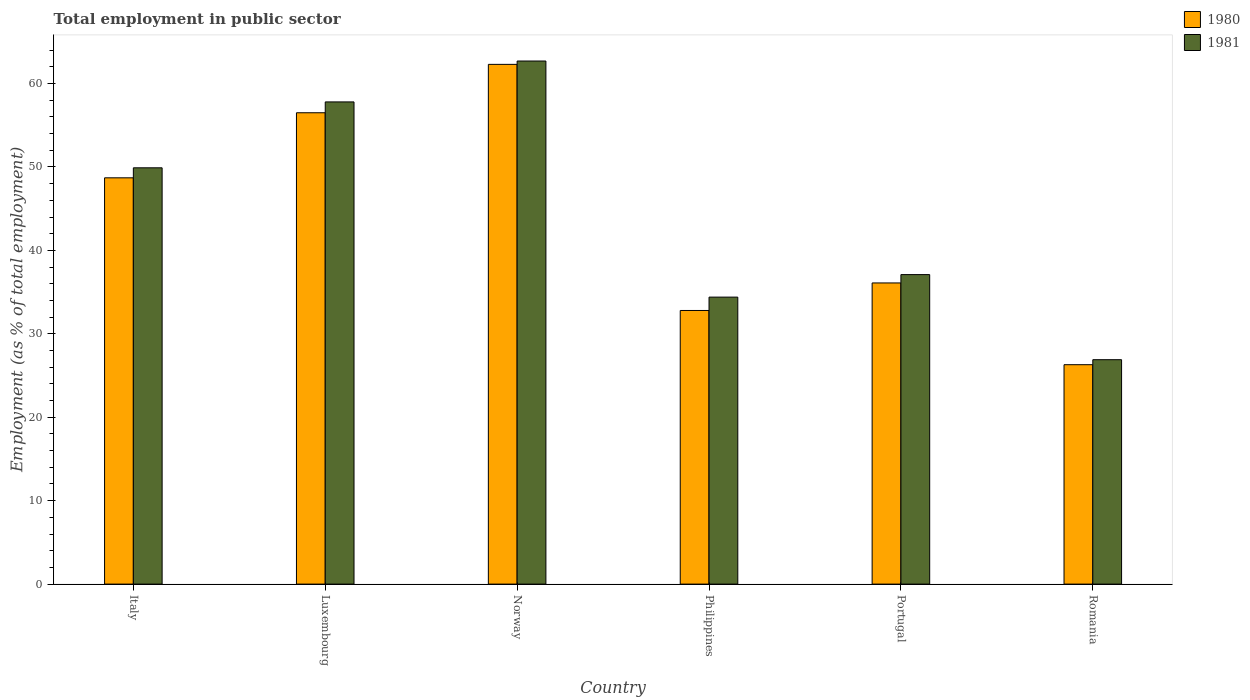How many different coloured bars are there?
Your answer should be compact. 2. How many groups of bars are there?
Your answer should be very brief. 6. How many bars are there on the 2nd tick from the right?
Your answer should be very brief. 2. What is the label of the 6th group of bars from the left?
Offer a terse response. Romania. What is the employment in public sector in 1981 in Luxembourg?
Provide a short and direct response. 57.8. Across all countries, what is the maximum employment in public sector in 1981?
Ensure brevity in your answer.  62.7. Across all countries, what is the minimum employment in public sector in 1981?
Your answer should be compact. 26.9. In which country was the employment in public sector in 1981 minimum?
Offer a very short reply. Romania. What is the total employment in public sector in 1980 in the graph?
Your response must be concise. 262.7. What is the difference between the employment in public sector in 1980 in Italy and that in Romania?
Keep it short and to the point. 22.4. What is the difference between the employment in public sector in 1980 in Romania and the employment in public sector in 1981 in Italy?
Your response must be concise. -23.6. What is the average employment in public sector in 1981 per country?
Give a very brief answer. 44.8. What is the difference between the employment in public sector of/in 1981 and employment in public sector of/in 1980 in Philippines?
Offer a terse response. 1.6. In how many countries, is the employment in public sector in 1981 greater than 16 %?
Keep it short and to the point. 6. What is the ratio of the employment in public sector in 1981 in Italy to that in Portugal?
Your response must be concise. 1.35. Is the employment in public sector in 1980 in Luxembourg less than that in Romania?
Provide a short and direct response. No. What is the difference between the highest and the second highest employment in public sector in 1981?
Make the answer very short. -4.9. What is the difference between the highest and the lowest employment in public sector in 1980?
Make the answer very short. 36. In how many countries, is the employment in public sector in 1980 greater than the average employment in public sector in 1980 taken over all countries?
Keep it short and to the point. 3. What does the 1st bar from the left in Luxembourg represents?
Offer a terse response. 1980. What does the 2nd bar from the right in Philippines represents?
Make the answer very short. 1980. Does the graph contain any zero values?
Your answer should be compact. No. How many legend labels are there?
Provide a succinct answer. 2. What is the title of the graph?
Provide a short and direct response. Total employment in public sector. What is the label or title of the Y-axis?
Keep it short and to the point. Employment (as % of total employment). What is the Employment (as % of total employment) in 1980 in Italy?
Offer a terse response. 48.7. What is the Employment (as % of total employment) of 1981 in Italy?
Provide a succinct answer. 49.9. What is the Employment (as % of total employment) in 1980 in Luxembourg?
Keep it short and to the point. 56.5. What is the Employment (as % of total employment) in 1981 in Luxembourg?
Your answer should be very brief. 57.8. What is the Employment (as % of total employment) of 1980 in Norway?
Keep it short and to the point. 62.3. What is the Employment (as % of total employment) in 1981 in Norway?
Your answer should be very brief. 62.7. What is the Employment (as % of total employment) of 1980 in Philippines?
Make the answer very short. 32.8. What is the Employment (as % of total employment) in 1981 in Philippines?
Your answer should be very brief. 34.4. What is the Employment (as % of total employment) of 1980 in Portugal?
Offer a very short reply. 36.1. What is the Employment (as % of total employment) in 1981 in Portugal?
Your answer should be compact. 37.1. What is the Employment (as % of total employment) in 1980 in Romania?
Ensure brevity in your answer.  26.3. What is the Employment (as % of total employment) of 1981 in Romania?
Provide a short and direct response. 26.9. Across all countries, what is the maximum Employment (as % of total employment) in 1980?
Give a very brief answer. 62.3. Across all countries, what is the maximum Employment (as % of total employment) of 1981?
Your answer should be very brief. 62.7. Across all countries, what is the minimum Employment (as % of total employment) of 1980?
Offer a very short reply. 26.3. Across all countries, what is the minimum Employment (as % of total employment) in 1981?
Ensure brevity in your answer.  26.9. What is the total Employment (as % of total employment) of 1980 in the graph?
Keep it short and to the point. 262.7. What is the total Employment (as % of total employment) of 1981 in the graph?
Ensure brevity in your answer.  268.8. What is the difference between the Employment (as % of total employment) in 1981 in Italy and that in Luxembourg?
Offer a terse response. -7.9. What is the difference between the Employment (as % of total employment) of 1980 in Italy and that in Philippines?
Ensure brevity in your answer.  15.9. What is the difference between the Employment (as % of total employment) in 1981 in Italy and that in Philippines?
Keep it short and to the point. 15.5. What is the difference between the Employment (as % of total employment) of 1980 in Italy and that in Romania?
Offer a terse response. 22.4. What is the difference between the Employment (as % of total employment) in 1980 in Luxembourg and that in Philippines?
Provide a succinct answer. 23.7. What is the difference between the Employment (as % of total employment) in 1981 in Luxembourg and that in Philippines?
Your answer should be compact. 23.4. What is the difference between the Employment (as % of total employment) of 1980 in Luxembourg and that in Portugal?
Your response must be concise. 20.4. What is the difference between the Employment (as % of total employment) in 1981 in Luxembourg and that in Portugal?
Offer a terse response. 20.7. What is the difference between the Employment (as % of total employment) in 1980 in Luxembourg and that in Romania?
Your answer should be very brief. 30.2. What is the difference between the Employment (as % of total employment) of 1981 in Luxembourg and that in Romania?
Provide a succinct answer. 30.9. What is the difference between the Employment (as % of total employment) of 1980 in Norway and that in Philippines?
Make the answer very short. 29.5. What is the difference between the Employment (as % of total employment) of 1981 in Norway and that in Philippines?
Make the answer very short. 28.3. What is the difference between the Employment (as % of total employment) of 1980 in Norway and that in Portugal?
Your answer should be very brief. 26.2. What is the difference between the Employment (as % of total employment) of 1981 in Norway and that in Portugal?
Ensure brevity in your answer.  25.6. What is the difference between the Employment (as % of total employment) of 1980 in Norway and that in Romania?
Your response must be concise. 36. What is the difference between the Employment (as % of total employment) of 1981 in Norway and that in Romania?
Provide a succinct answer. 35.8. What is the difference between the Employment (as % of total employment) in 1981 in Philippines and that in Portugal?
Give a very brief answer. -2.7. What is the difference between the Employment (as % of total employment) of 1980 in Philippines and that in Romania?
Your answer should be very brief. 6.5. What is the difference between the Employment (as % of total employment) of 1980 in Italy and the Employment (as % of total employment) of 1981 in Luxembourg?
Offer a very short reply. -9.1. What is the difference between the Employment (as % of total employment) of 1980 in Italy and the Employment (as % of total employment) of 1981 in Norway?
Keep it short and to the point. -14. What is the difference between the Employment (as % of total employment) in 1980 in Italy and the Employment (as % of total employment) in 1981 in Romania?
Offer a terse response. 21.8. What is the difference between the Employment (as % of total employment) of 1980 in Luxembourg and the Employment (as % of total employment) of 1981 in Norway?
Provide a succinct answer. -6.2. What is the difference between the Employment (as % of total employment) of 1980 in Luxembourg and the Employment (as % of total employment) of 1981 in Philippines?
Ensure brevity in your answer.  22.1. What is the difference between the Employment (as % of total employment) of 1980 in Luxembourg and the Employment (as % of total employment) of 1981 in Romania?
Ensure brevity in your answer.  29.6. What is the difference between the Employment (as % of total employment) in 1980 in Norway and the Employment (as % of total employment) in 1981 in Philippines?
Ensure brevity in your answer.  27.9. What is the difference between the Employment (as % of total employment) of 1980 in Norway and the Employment (as % of total employment) of 1981 in Portugal?
Your response must be concise. 25.2. What is the difference between the Employment (as % of total employment) in 1980 in Norway and the Employment (as % of total employment) in 1981 in Romania?
Your answer should be very brief. 35.4. What is the difference between the Employment (as % of total employment) in 1980 in Philippines and the Employment (as % of total employment) in 1981 in Romania?
Your response must be concise. 5.9. What is the average Employment (as % of total employment) in 1980 per country?
Ensure brevity in your answer.  43.78. What is the average Employment (as % of total employment) of 1981 per country?
Your answer should be compact. 44.8. What is the difference between the Employment (as % of total employment) of 1980 and Employment (as % of total employment) of 1981 in Norway?
Keep it short and to the point. -0.4. What is the difference between the Employment (as % of total employment) of 1980 and Employment (as % of total employment) of 1981 in Philippines?
Keep it short and to the point. -1.6. What is the difference between the Employment (as % of total employment) in 1980 and Employment (as % of total employment) in 1981 in Portugal?
Your response must be concise. -1. What is the ratio of the Employment (as % of total employment) of 1980 in Italy to that in Luxembourg?
Offer a very short reply. 0.86. What is the ratio of the Employment (as % of total employment) in 1981 in Italy to that in Luxembourg?
Your answer should be very brief. 0.86. What is the ratio of the Employment (as % of total employment) in 1980 in Italy to that in Norway?
Ensure brevity in your answer.  0.78. What is the ratio of the Employment (as % of total employment) of 1981 in Italy to that in Norway?
Keep it short and to the point. 0.8. What is the ratio of the Employment (as % of total employment) of 1980 in Italy to that in Philippines?
Offer a very short reply. 1.48. What is the ratio of the Employment (as % of total employment) in 1981 in Italy to that in Philippines?
Ensure brevity in your answer.  1.45. What is the ratio of the Employment (as % of total employment) in 1980 in Italy to that in Portugal?
Keep it short and to the point. 1.35. What is the ratio of the Employment (as % of total employment) in 1981 in Italy to that in Portugal?
Offer a very short reply. 1.34. What is the ratio of the Employment (as % of total employment) of 1980 in Italy to that in Romania?
Your response must be concise. 1.85. What is the ratio of the Employment (as % of total employment) of 1981 in Italy to that in Romania?
Provide a short and direct response. 1.85. What is the ratio of the Employment (as % of total employment) in 1980 in Luxembourg to that in Norway?
Your response must be concise. 0.91. What is the ratio of the Employment (as % of total employment) of 1981 in Luxembourg to that in Norway?
Make the answer very short. 0.92. What is the ratio of the Employment (as % of total employment) in 1980 in Luxembourg to that in Philippines?
Make the answer very short. 1.72. What is the ratio of the Employment (as % of total employment) of 1981 in Luxembourg to that in Philippines?
Give a very brief answer. 1.68. What is the ratio of the Employment (as % of total employment) in 1980 in Luxembourg to that in Portugal?
Your answer should be compact. 1.57. What is the ratio of the Employment (as % of total employment) of 1981 in Luxembourg to that in Portugal?
Your answer should be compact. 1.56. What is the ratio of the Employment (as % of total employment) of 1980 in Luxembourg to that in Romania?
Ensure brevity in your answer.  2.15. What is the ratio of the Employment (as % of total employment) of 1981 in Luxembourg to that in Romania?
Offer a terse response. 2.15. What is the ratio of the Employment (as % of total employment) of 1980 in Norway to that in Philippines?
Keep it short and to the point. 1.9. What is the ratio of the Employment (as % of total employment) of 1981 in Norway to that in Philippines?
Keep it short and to the point. 1.82. What is the ratio of the Employment (as % of total employment) in 1980 in Norway to that in Portugal?
Provide a short and direct response. 1.73. What is the ratio of the Employment (as % of total employment) of 1981 in Norway to that in Portugal?
Offer a terse response. 1.69. What is the ratio of the Employment (as % of total employment) in 1980 in Norway to that in Romania?
Your answer should be very brief. 2.37. What is the ratio of the Employment (as % of total employment) in 1981 in Norway to that in Romania?
Ensure brevity in your answer.  2.33. What is the ratio of the Employment (as % of total employment) in 1980 in Philippines to that in Portugal?
Offer a very short reply. 0.91. What is the ratio of the Employment (as % of total employment) of 1981 in Philippines to that in Portugal?
Provide a succinct answer. 0.93. What is the ratio of the Employment (as % of total employment) in 1980 in Philippines to that in Romania?
Offer a terse response. 1.25. What is the ratio of the Employment (as % of total employment) in 1981 in Philippines to that in Romania?
Give a very brief answer. 1.28. What is the ratio of the Employment (as % of total employment) of 1980 in Portugal to that in Romania?
Offer a terse response. 1.37. What is the ratio of the Employment (as % of total employment) of 1981 in Portugal to that in Romania?
Offer a very short reply. 1.38. What is the difference between the highest and the lowest Employment (as % of total employment) in 1980?
Provide a succinct answer. 36. What is the difference between the highest and the lowest Employment (as % of total employment) in 1981?
Your response must be concise. 35.8. 